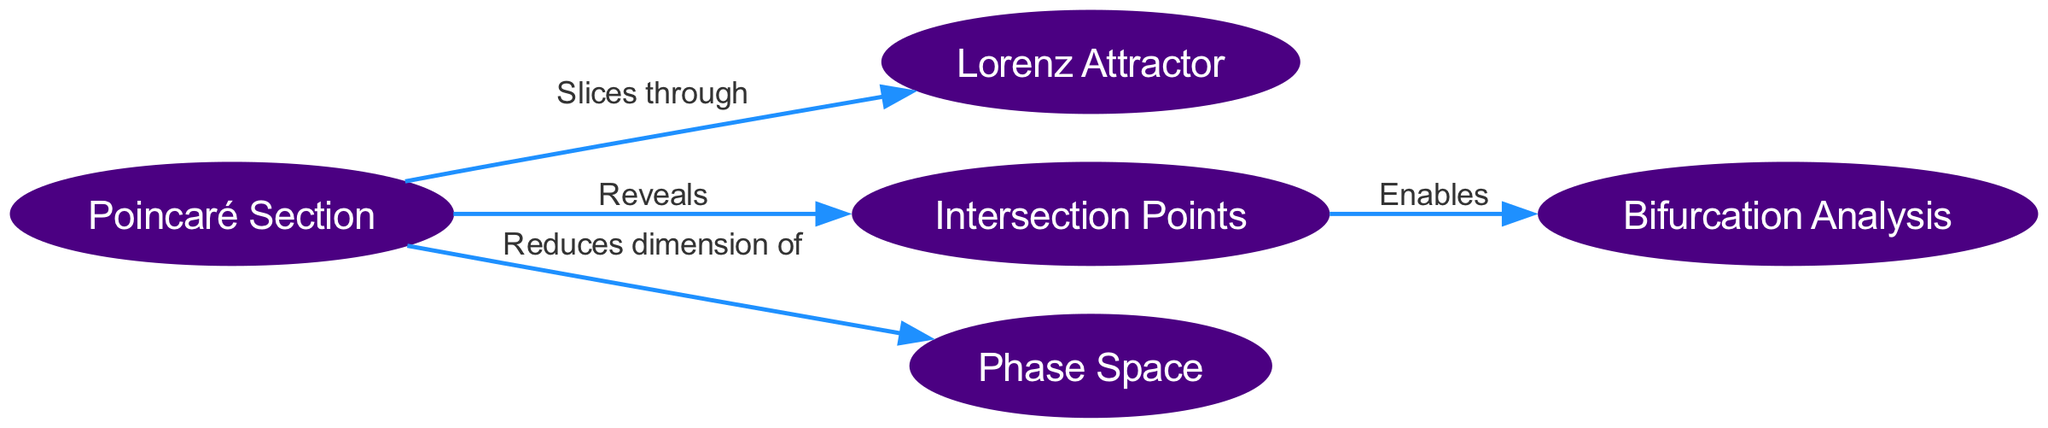What does the Poincaré Section reveal? The edge connecting the Poincaré Section node to the Intersection Points node is labeled "Reveals." This indicates that the Poincaré Section provides insights into the intersection points in the phase space.
Answer: Intersection Points How many nodes are in the diagram? By counting the nodes listed in the data, we find there are five distinct nodes: Poincaré Section, Lorenz Attractor, Intersection Points, Phase Space, and Bifurcation Analysis. Thus, the total is five.
Answer: Five What dimension does the Poincaré Section reduce for Phase Space? Looking at the edge from the Poincaré Section to Phase Space, it states "Reduces dimension of," inferring that the analysis through the Poincaré Section simplifies the nature of the Phase Space by reducing its dimensional complexity.
Answer: Dimension Which node connects to Bifurcation Analysis? The edge from Intersection Points to Bifurcation Analysis indicates that the Intersection Points enable insights related to Bifurcation Analysis. This establishes a direct connection between these two nodes.
Answer: Intersection Points What is the relationship between Poincaré Section and Lorenz Attractor? The diagram shows an edge labeled "Slices through" connecting the Poincaré Section and the Lorenz Attractor, indicating that the Poincaré Section provides slices or cross-sections through the Lorenz Attractor.
Answer: Slices through 